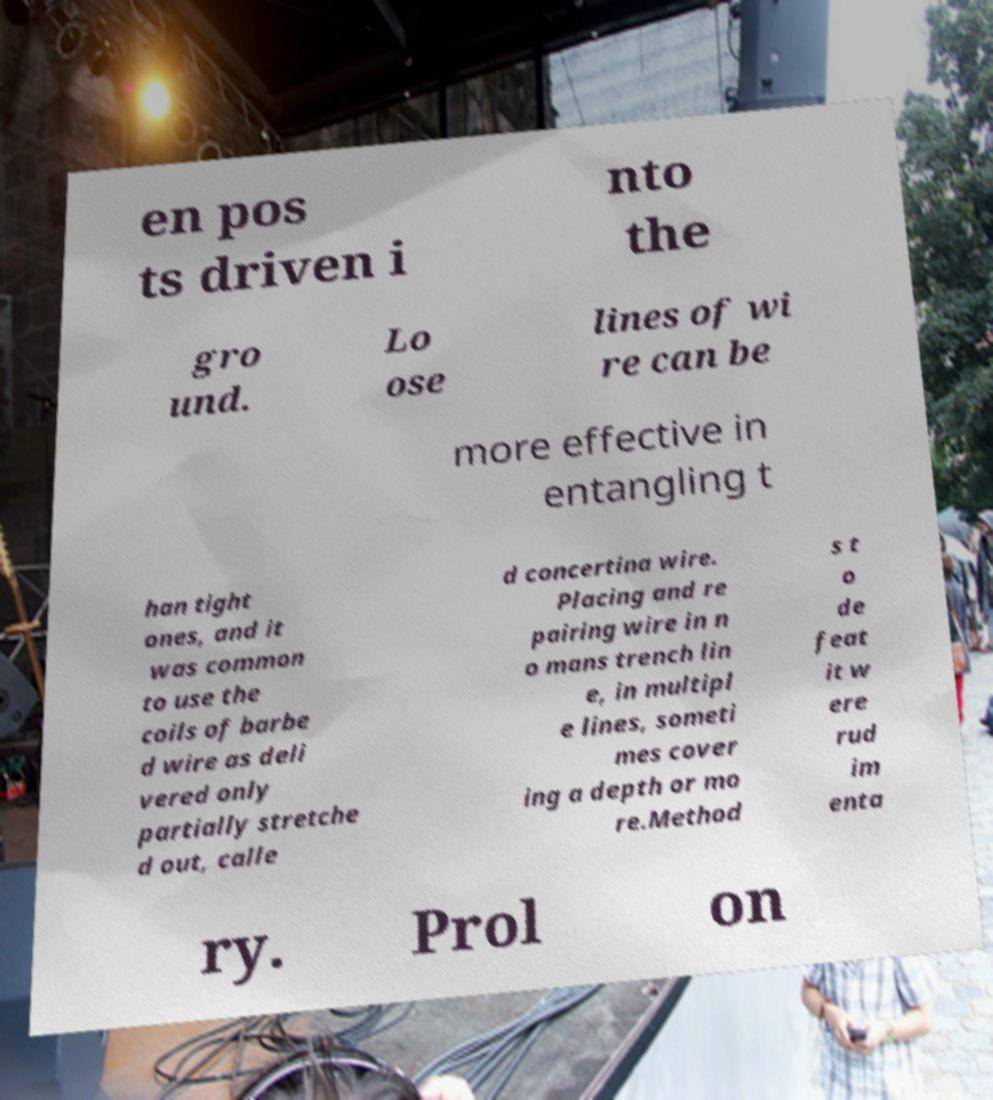Could you assist in decoding the text presented in this image and type it out clearly? en pos ts driven i nto the gro und. Lo ose lines of wi re can be more effective in entangling t han tight ones, and it was common to use the coils of barbe d wire as deli vered only partially stretche d out, calle d concertina wire. Placing and re pairing wire in n o mans trench lin e, in multipl e lines, someti mes cover ing a depth or mo re.Method s t o de feat it w ere rud im enta ry. Prol on 